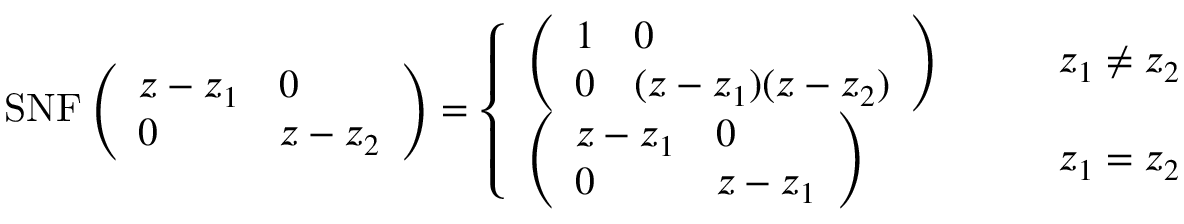<formula> <loc_0><loc_0><loc_500><loc_500>S N F \left ( \begin{array} { l l } { z - z _ { 1 } } & { 0 } \\ { 0 } & { z - z _ { 2 } } \end{array} \right ) = \left \{ \begin{array} { l l } { \left ( \begin{array} { l l } { 1 } & { 0 } \\ { 0 } & { ( z - z _ { 1 } ) ( z - z _ { 2 } ) } \end{array} \right ) } & { \quad z _ { 1 } \neq z _ { 2 } } \\ { \left ( \begin{array} { l l } { z - z _ { 1 } } & { 0 } \\ { 0 } & { z - z _ { 1 } } \end{array} \right ) } & { \quad z _ { 1 } = z _ { 2 } } \end{array}</formula> 